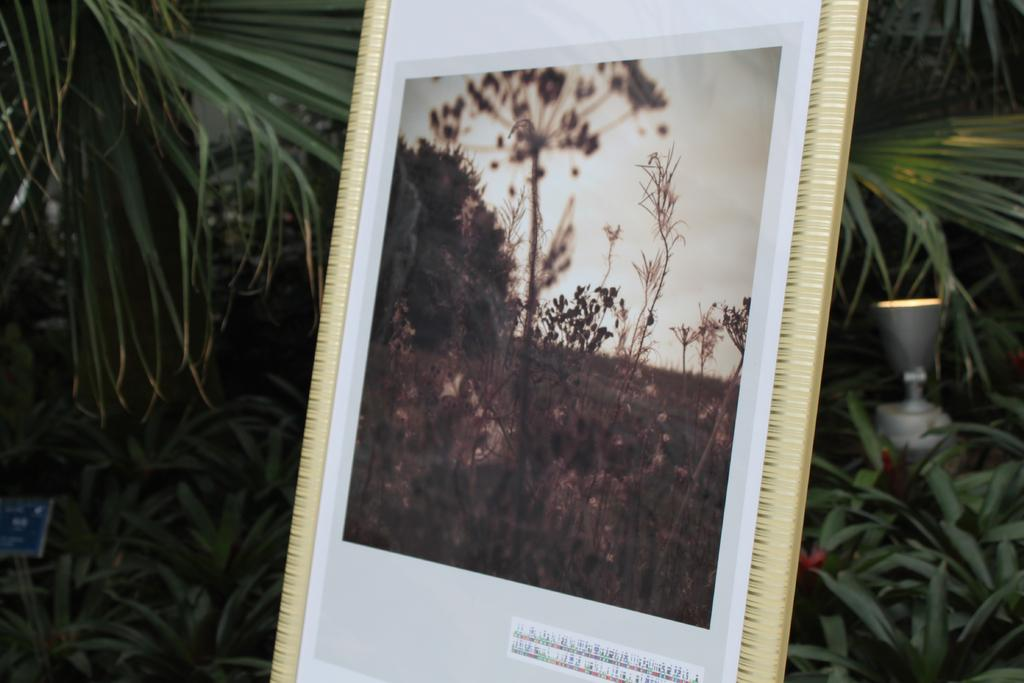What object in the image is used for displaying photos? There is a photo frame in the image. What type of living organisms can be seen in the image? Plants are visible in the image. What can be used for illumination in the image? There are lights in the image. Where is the nearest store to the photo frame in the image? There is no information about a store in the image, so it cannot be determined. What type of board is being used to support the plants in the image? There is no board present in the image; the plants are not shown to be supported by any board. 